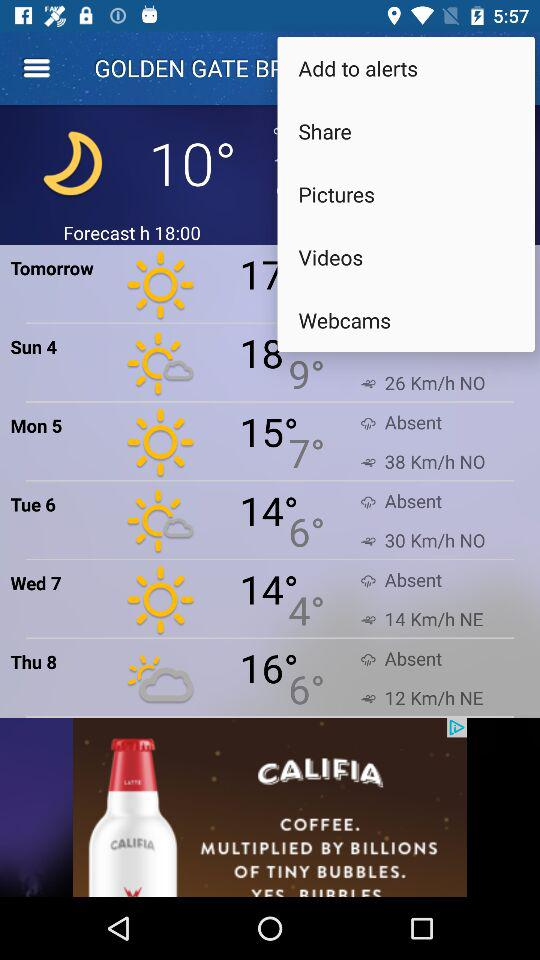What will be the minimum temperature on Sunday, 4? The minimum temperature will be 9°. 